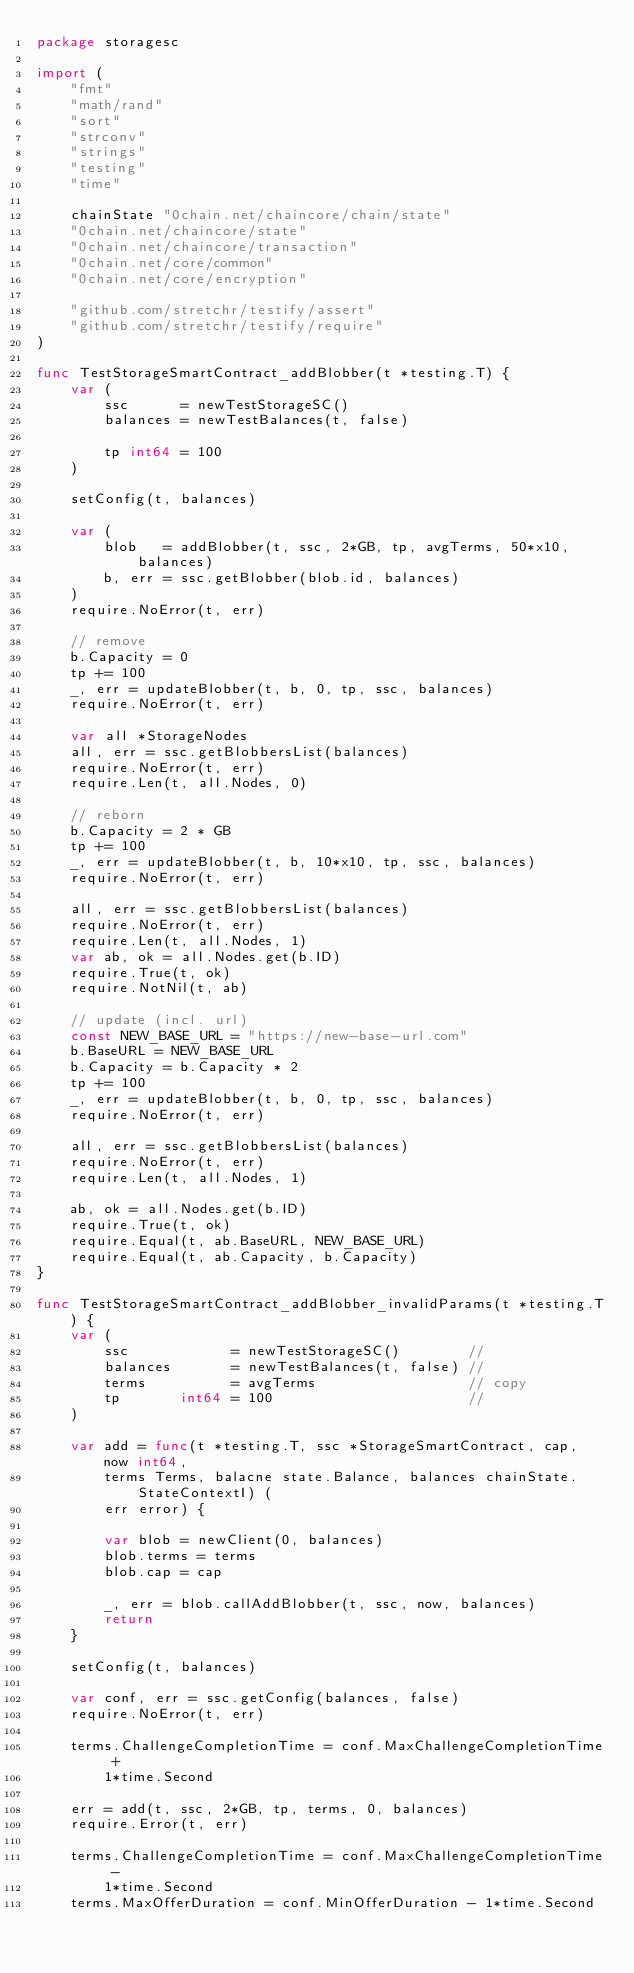Convert code to text. <code><loc_0><loc_0><loc_500><loc_500><_Go_>package storagesc

import (
	"fmt"
	"math/rand"
	"sort"
	"strconv"
	"strings"
	"testing"
	"time"

	chainState "0chain.net/chaincore/chain/state"
	"0chain.net/chaincore/state"
	"0chain.net/chaincore/transaction"
	"0chain.net/core/common"
	"0chain.net/core/encryption"

	"github.com/stretchr/testify/assert"
	"github.com/stretchr/testify/require"
)

func TestStorageSmartContract_addBlobber(t *testing.T) {
	var (
		ssc      = newTestStorageSC()
		balances = newTestBalances(t, false)

		tp int64 = 100
	)

	setConfig(t, balances)

	var (
		blob   = addBlobber(t, ssc, 2*GB, tp, avgTerms, 50*x10, balances)
		b, err = ssc.getBlobber(blob.id, balances)
	)
	require.NoError(t, err)

	// remove
	b.Capacity = 0
	tp += 100
	_, err = updateBlobber(t, b, 0, tp, ssc, balances)
	require.NoError(t, err)

	var all *StorageNodes
	all, err = ssc.getBlobbersList(balances)
	require.NoError(t, err)
	require.Len(t, all.Nodes, 0)

	// reborn
	b.Capacity = 2 * GB
	tp += 100
	_, err = updateBlobber(t, b, 10*x10, tp, ssc, balances)
	require.NoError(t, err)

	all, err = ssc.getBlobbersList(balances)
	require.NoError(t, err)
	require.Len(t, all.Nodes, 1)
	var ab, ok = all.Nodes.get(b.ID)
	require.True(t, ok)
	require.NotNil(t, ab)

	// update (incl. url)
	const NEW_BASE_URL = "https://new-base-url.com"
	b.BaseURL = NEW_BASE_URL
	b.Capacity = b.Capacity * 2
	tp += 100
	_, err = updateBlobber(t, b, 0, tp, ssc, balances)
	require.NoError(t, err)

	all, err = ssc.getBlobbersList(balances)
	require.NoError(t, err)
	require.Len(t, all.Nodes, 1)

	ab, ok = all.Nodes.get(b.ID)
	require.True(t, ok)
	require.Equal(t, ab.BaseURL, NEW_BASE_URL)
	require.Equal(t, ab.Capacity, b.Capacity)
}

func TestStorageSmartContract_addBlobber_invalidParams(t *testing.T) {
	var (
		ssc            = newTestStorageSC()        //
		balances       = newTestBalances(t, false) //
		terms          = avgTerms                  // copy
		tp       int64 = 100                       //
	)

	var add = func(t *testing.T, ssc *StorageSmartContract, cap, now int64,
		terms Terms, balacne state.Balance, balances chainState.StateContextI) (
		err error) {

		var blob = newClient(0, balances)
		blob.terms = terms
		blob.cap = cap

		_, err = blob.callAddBlobber(t, ssc, now, balances)
		return
	}

	setConfig(t, balances)

	var conf, err = ssc.getConfig(balances, false)
	require.NoError(t, err)

	terms.ChallengeCompletionTime = conf.MaxChallengeCompletionTime +
		1*time.Second

	err = add(t, ssc, 2*GB, tp, terms, 0, balances)
	require.Error(t, err)

	terms.ChallengeCompletionTime = conf.MaxChallengeCompletionTime -
		1*time.Second
	terms.MaxOfferDuration = conf.MinOfferDuration - 1*time.Second</code> 